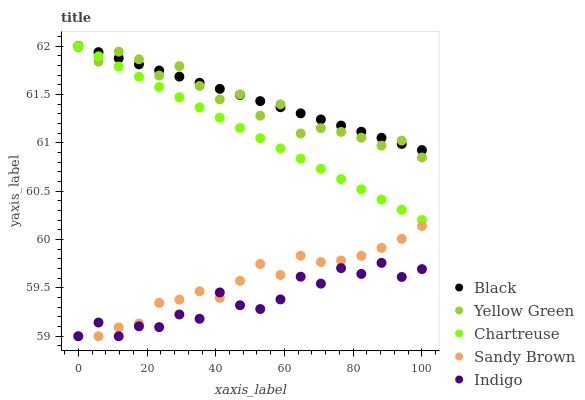Does Indigo have the minimum area under the curve?
Answer yes or no. Yes. Does Black have the maximum area under the curve?
Answer yes or no. Yes. Does Chartreuse have the minimum area under the curve?
Answer yes or no. No. Does Chartreuse have the maximum area under the curve?
Answer yes or no. No. Is Chartreuse the smoothest?
Answer yes or no. Yes. Is Indigo the roughest?
Answer yes or no. Yes. Is Black the smoothest?
Answer yes or no. No. Is Black the roughest?
Answer yes or no. No. Does Sandy Brown have the lowest value?
Answer yes or no. Yes. Does Chartreuse have the lowest value?
Answer yes or no. No. Does Black have the highest value?
Answer yes or no. Yes. Does Yellow Green have the highest value?
Answer yes or no. No. Is Indigo less than Yellow Green?
Answer yes or no. Yes. Is Yellow Green greater than Sandy Brown?
Answer yes or no. Yes. Does Indigo intersect Sandy Brown?
Answer yes or no. Yes. Is Indigo less than Sandy Brown?
Answer yes or no. No. Is Indigo greater than Sandy Brown?
Answer yes or no. No. Does Indigo intersect Yellow Green?
Answer yes or no. No. 